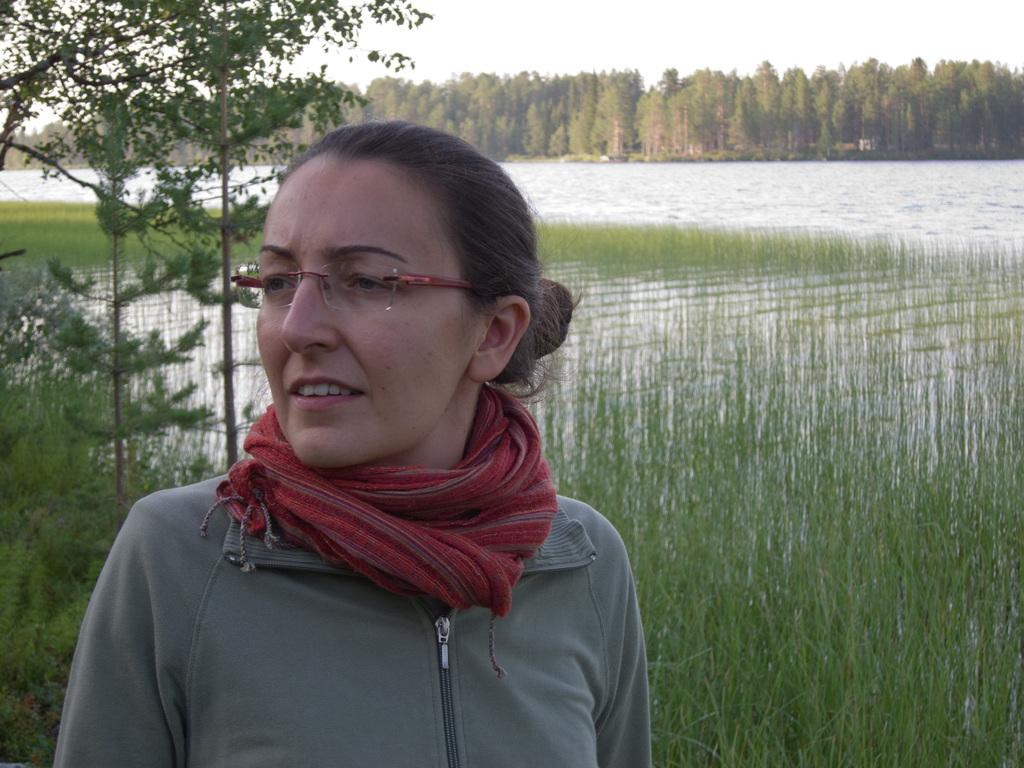Who is the main subject in the image? There is a woman in the image. What accessories is the woman wearing? The woman is wearing spectacles, a scarf, and a jacket. What can be seen in the background of the image? Water, grass, trees, and the sky are visible in the background of the image. What type of knowledge can be seen in the woman's hand in the image? There is no knowledge visible in the woman's hand in the image. What type of glass is the woman holding in the image? There is no glass present in the image. 